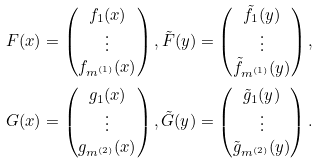<formula> <loc_0><loc_0><loc_500><loc_500>& F ( x ) = \begin{pmatrix} f _ { 1 } ( x ) \\ \vdots \\ f _ { m ^ { ( 1 ) } } ( x ) \end{pmatrix} , \tilde { F } ( y ) = \begin{pmatrix} \tilde { f } _ { 1 } ( y ) \\ \vdots \\ \tilde { f } _ { m ^ { ( 1 ) } } ( y ) \end{pmatrix} , \\ & G ( x ) = \begin{pmatrix} g _ { 1 } ( x ) \\ \vdots \\ g _ { m ^ { ( 2 ) } } ( x ) \end{pmatrix} , \tilde { G } ( y ) = \begin{pmatrix} \tilde { g } _ { 1 } ( y ) \\ \vdots \\ \tilde { g } _ { m ^ { ( 2 ) } } ( y ) \end{pmatrix} .</formula> 